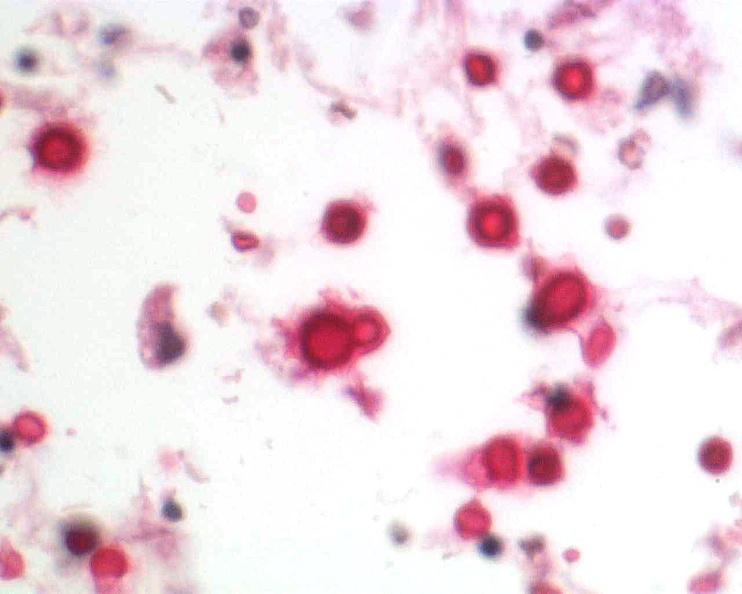s nervous present?
Answer the question using a single word or phrase. Yes 